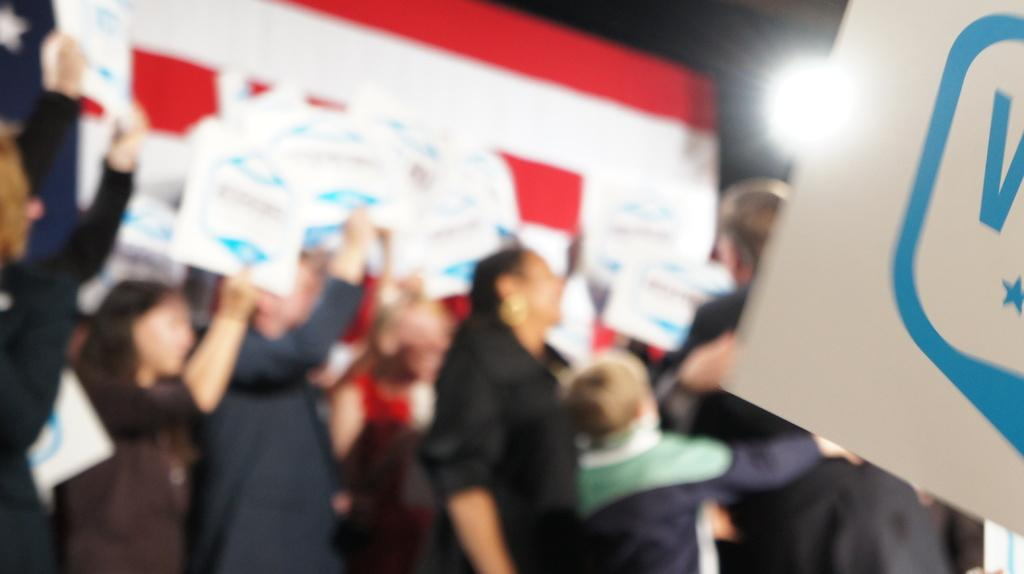What are the people in the image doing? The people in the image are standing and holding posters. What else can be seen in the image besides the people? There is a banner and a light in the image. What type of cloud can be seen in the image? There are no clouds visible in the image. What is the secretary doing in the image? There is no secretary present in the image. 